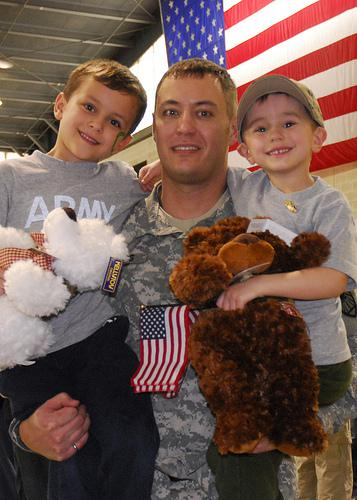Question: where are the boys?
Choices:
A. Standing next to parents.
B. On the ride.
C. In their father's arms.
D. On the pool.
Answer with the letter. Answer: C Question: what is the man holding?
Choices:
A. A baby.
B. Children.
C. His phone.
D. His sons.
Answer with the letter. Answer: D Question: what is hanging behind the people?
Choices:
A. A sign.
B. An American flag.
C. A banner.
D. An Italian flag.
Answer with the letter. Answer: B Question: how many people are there?
Choices:
A. Four.
B. Two.
C. One.
D. Three.
Answer with the letter. Answer: D Question: when was the photo taken?
Choices:
A. When they returned home.
B. When the man came home from deployment.
C. At the hospital.
D. In the house.
Answer with the letter. Answer: B 